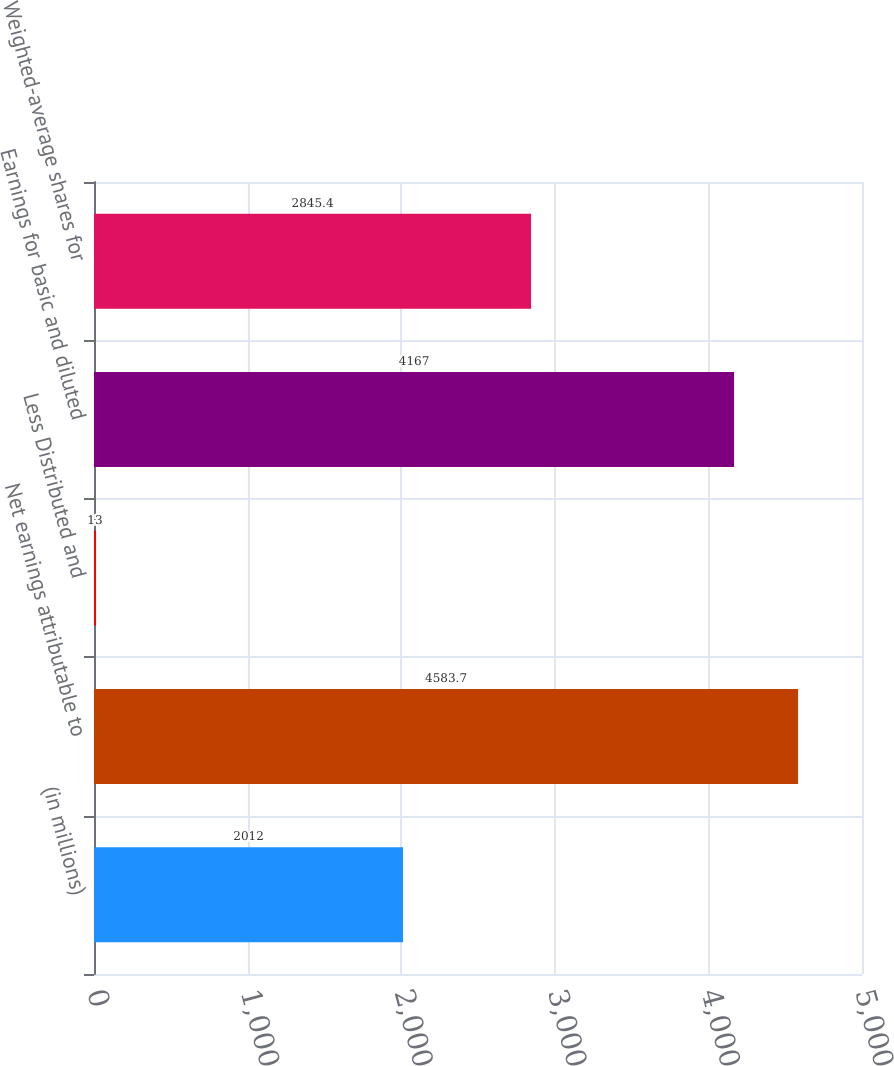Convert chart to OTSL. <chart><loc_0><loc_0><loc_500><loc_500><bar_chart><fcel>(in millions)<fcel>Net earnings attributable to<fcel>Less Distributed and<fcel>Earnings for basic and diluted<fcel>Weighted-average shares for<nl><fcel>2012<fcel>4583.7<fcel>13<fcel>4167<fcel>2845.4<nl></chart> 